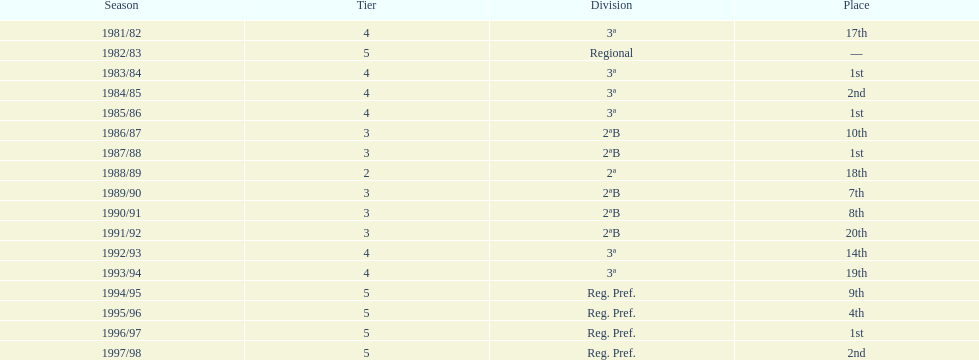How many seasons are shown in this chart? 17. 